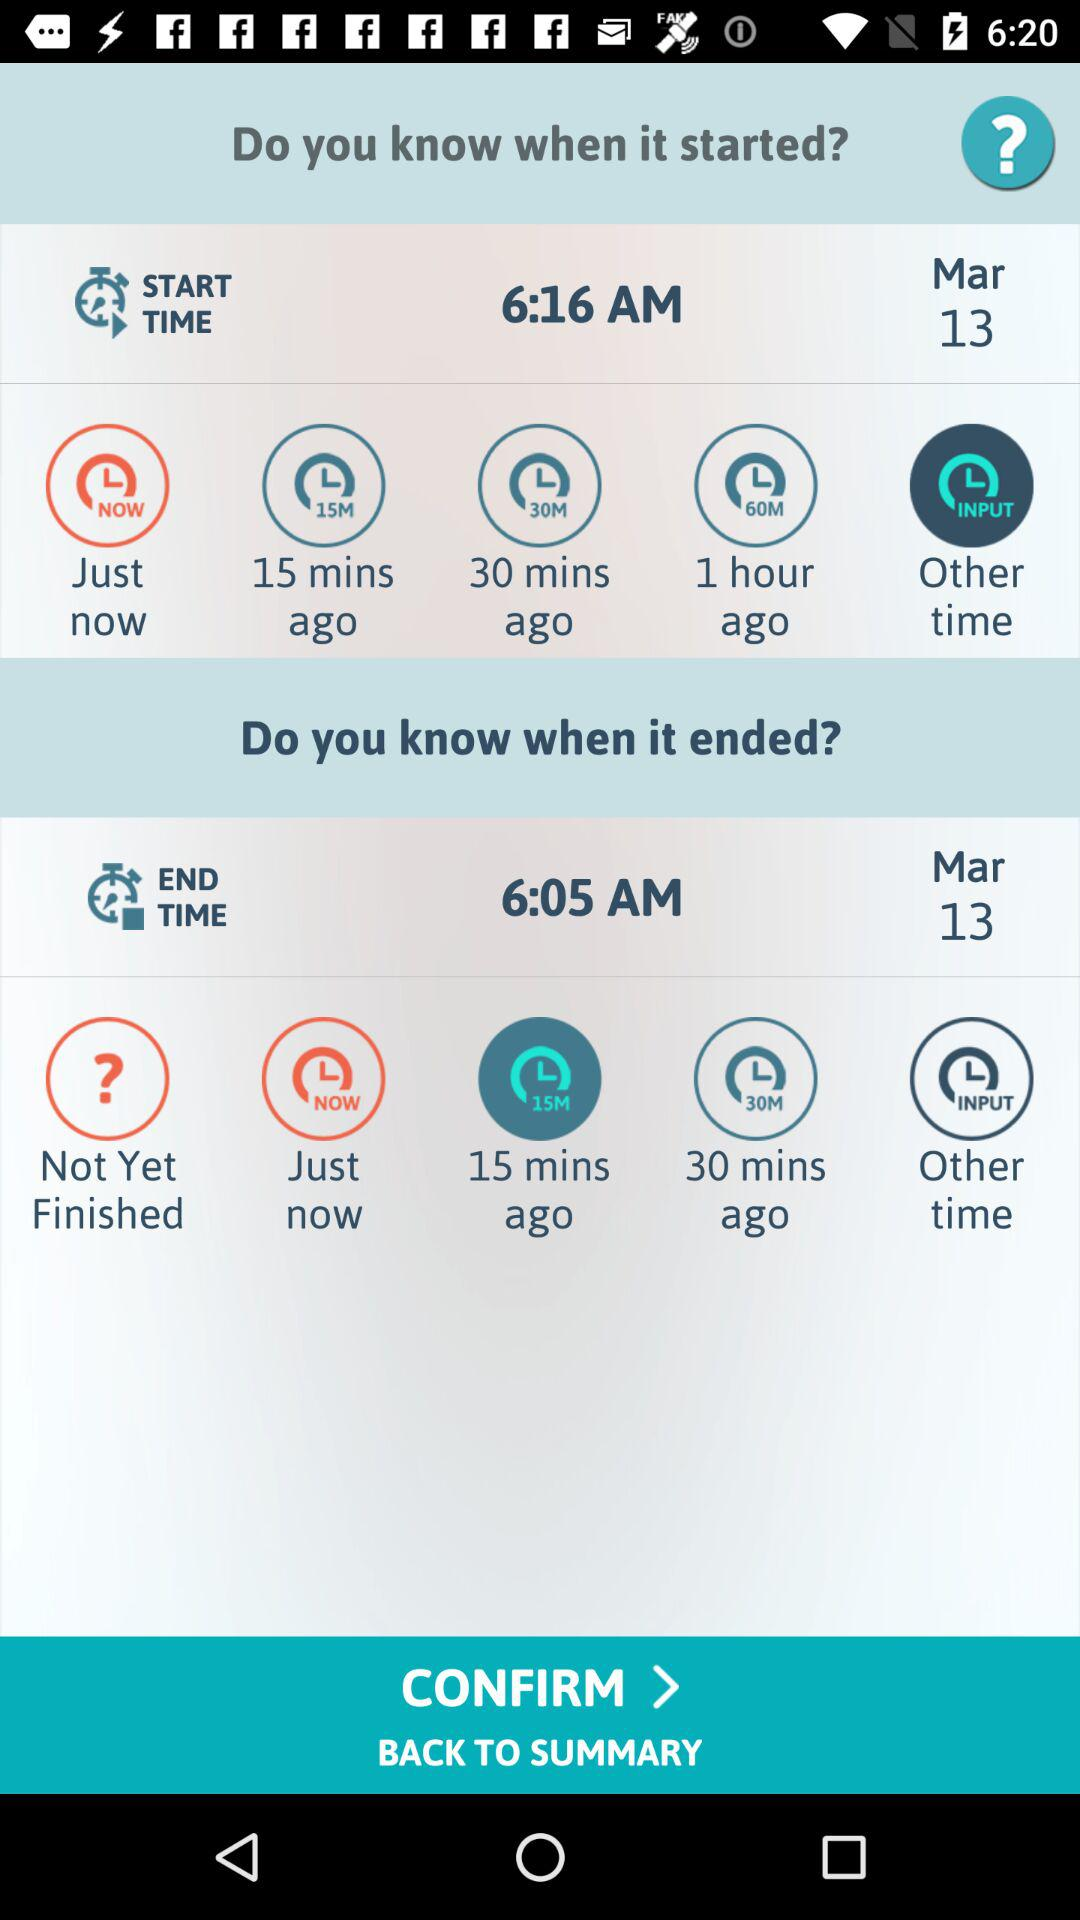What is the start time? The start time is 6:16 AM. 